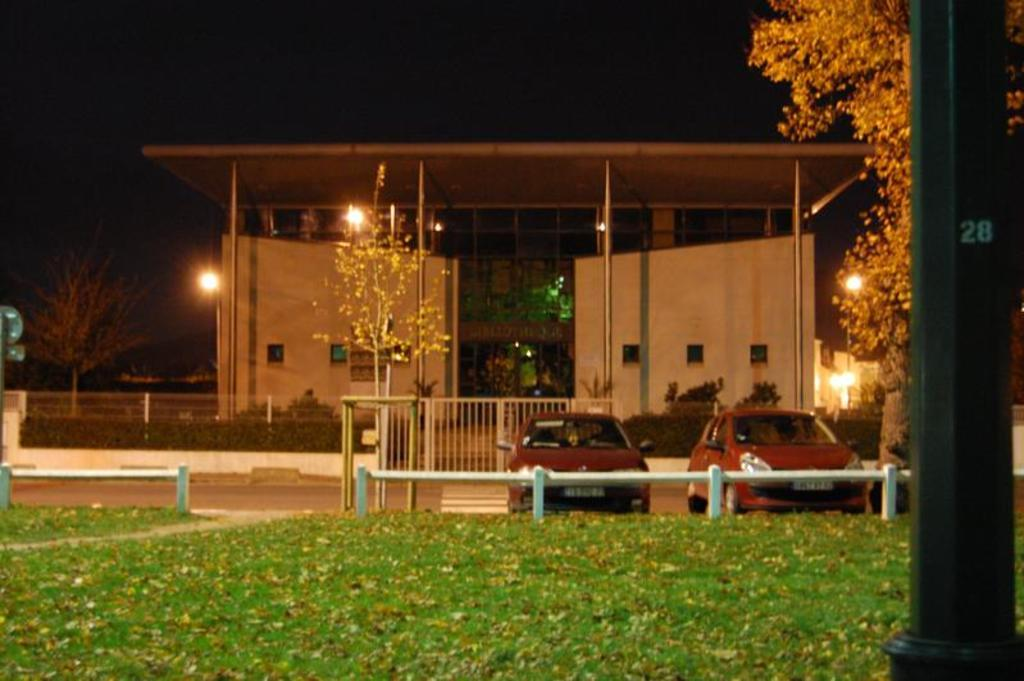What type of surface is visible on the ground in the image? There is grass on the ground in the image. How many cars can be seen in the image? There are two cars in the image. What type of building is present in the image? There is a house in the image. Can you describe any other structures in the image? There is a shed in the image. What is located on the right side of the image? There is a tree on the right side of the image. What can be seen illuminating the scene in the image? There are lights visible in the image. What type of meal is being prepared in the scene depicted in the image? There is no scene or meal preparation visible in the image; it features a house, a shed, a tree, and lights. 